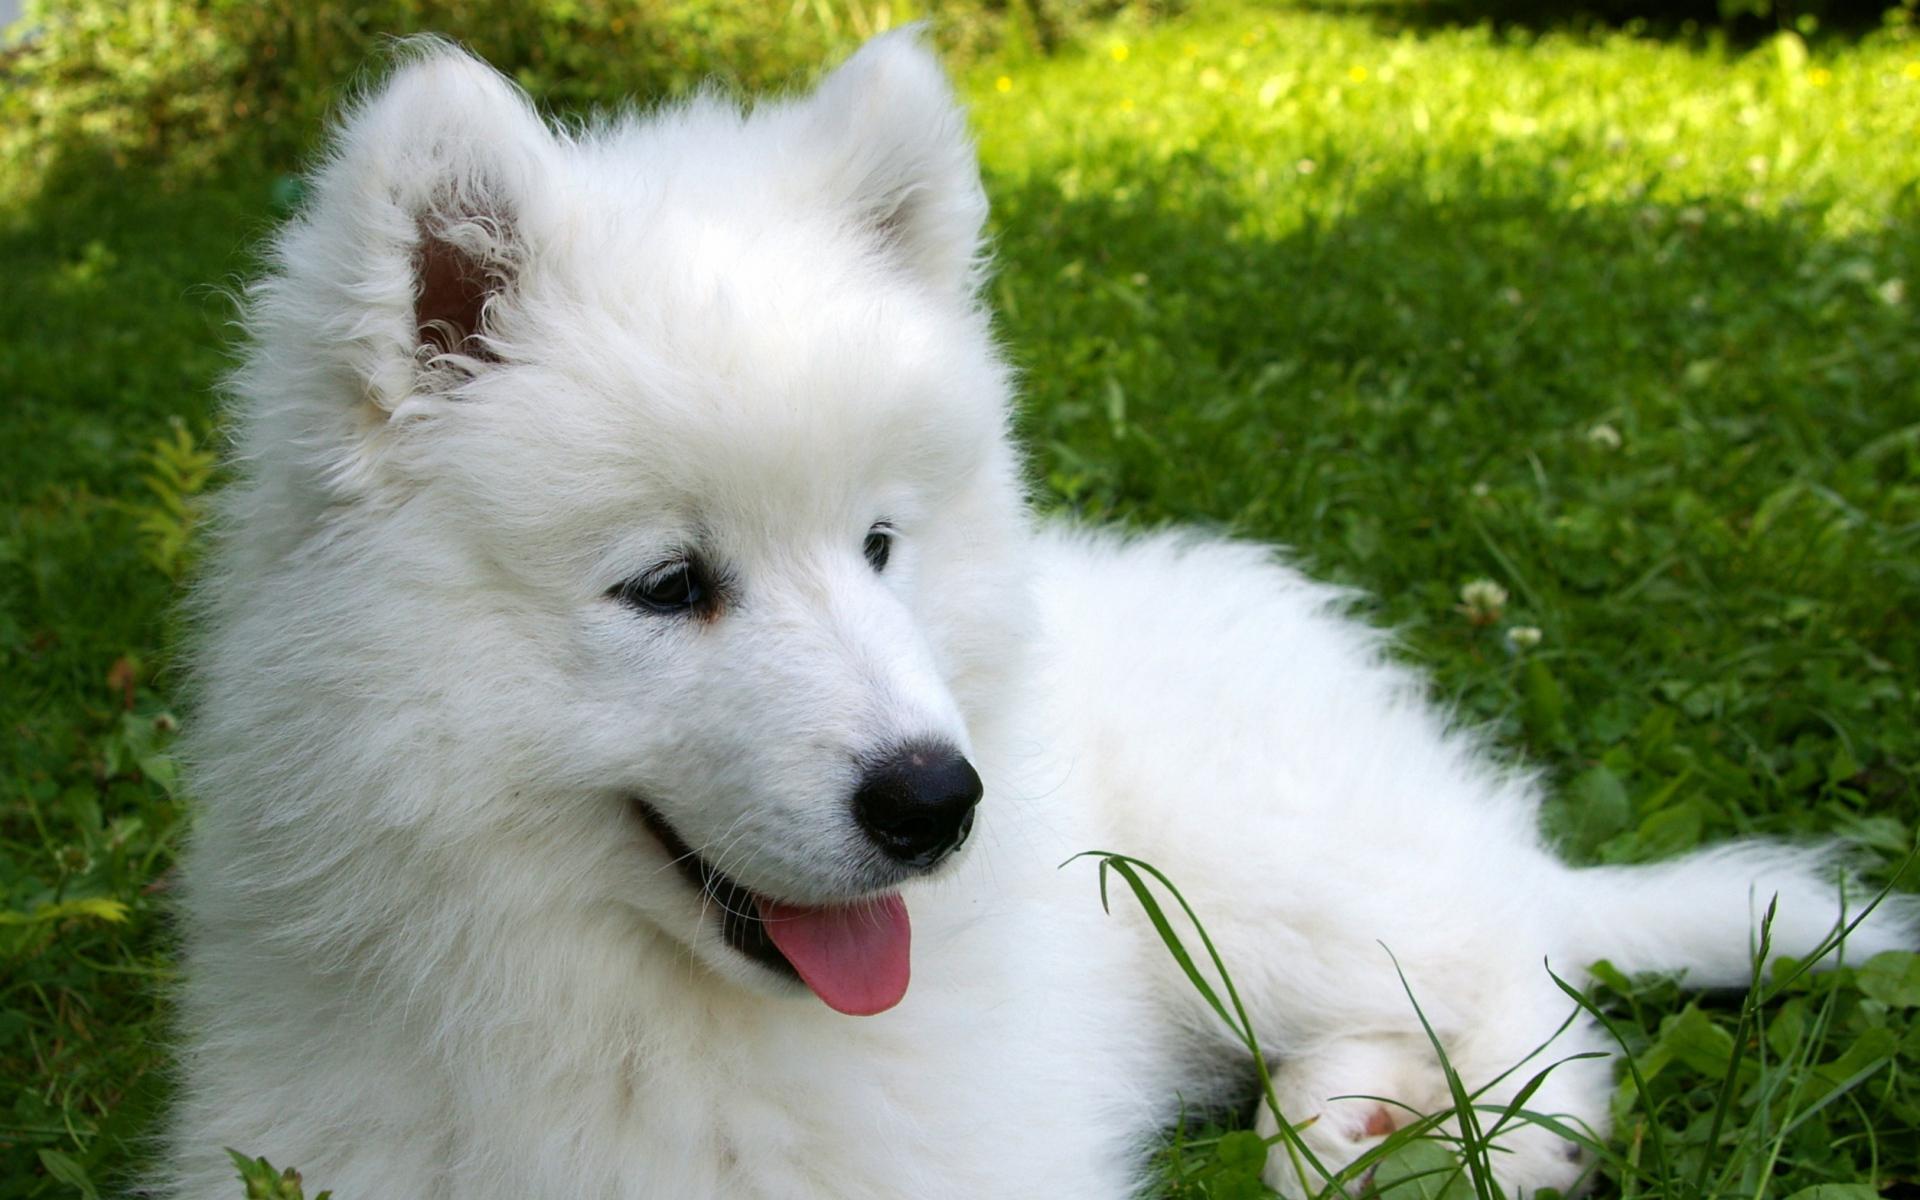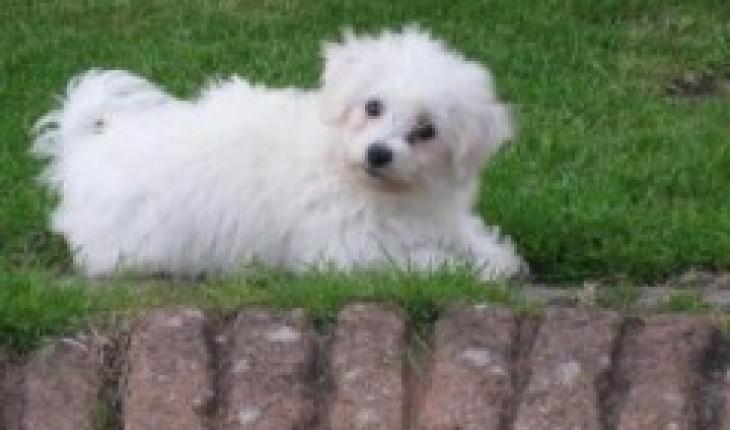The first image is the image on the left, the second image is the image on the right. Given the left and right images, does the statement "Each image contains exactly one dog, and all dogs are white and posed outdoors." hold true? Answer yes or no. Yes. The first image is the image on the left, the second image is the image on the right. Evaluate the accuracy of this statement regarding the images: "The dog in the image on the right is standing on the grass.". Is it true? Answer yes or no. No. 